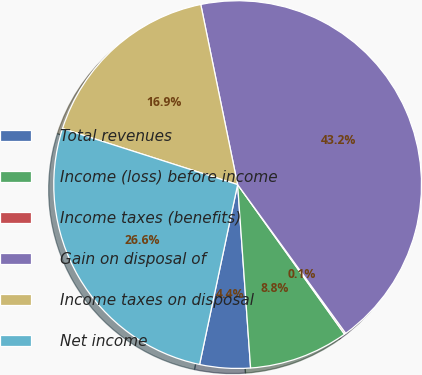<chart> <loc_0><loc_0><loc_500><loc_500><pie_chart><fcel>Total revenues<fcel>Income (loss) before income<fcel>Income taxes (benefits)<fcel>Gain on disposal of<fcel>Income taxes on disposal<fcel>Net income<nl><fcel>4.44%<fcel>8.75%<fcel>0.13%<fcel>43.21%<fcel>16.86%<fcel>26.61%<nl></chart> 